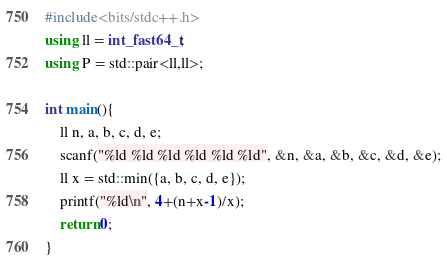<code> <loc_0><loc_0><loc_500><loc_500><_C++_>#include<bits/stdc++.h>
using ll = int_fast64_t;
using P = std::pair<ll,ll>;

int main(){
	ll n, a, b, c, d, e;
	scanf("%ld %ld %ld %ld %ld %ld", &n, &a, &b, &c, &d, &e);
	ll x = std::min({a, b, c, d, e});
	printf("%ld\n", 4+(n+x-1)/x);
	return 0;
}
</code> 